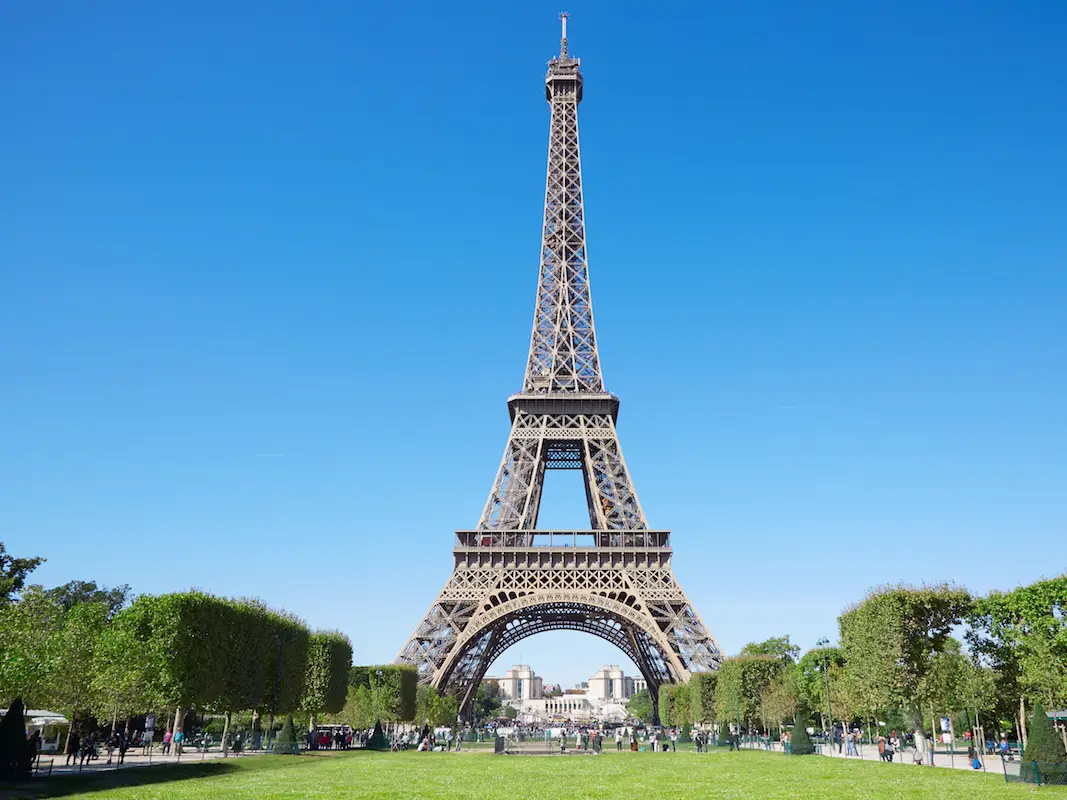What do you see happening in this image? The image beautifully captures the Eiffel Tower on a sunny day in Paris. Constructed of an iron lattice, the tower rises majestically against a cloudless blue sky, flanked by lush green trees. The dark hue of the iron contrasts with the bright green of the trees and the deep blue of the sky, drawing the viewer's eye upwards to its summit. People at the base of the tower provide a scale, emphasizing its grandeur. This scene not only showcases the tower as an architectural feat but also as a beloved gathering place for both tourists and locals enjoying a day out in the Champ de Mars park. 